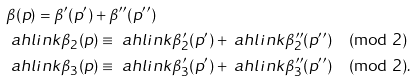<formula> <loc_0><loc_0><loc_500><loc_500>& \beta ( p ) = \beta ^ { \prime } ( p ^ { \prime } ) + \beta ^ { \prime \prime } ( p ^ { \prime \prime } ) \\ & \ a h l i n k \beta _ { 2 } ( p ) \equiv \ a h l i n k \beta ^ { \prime } _ { 2 } ( p ^ { \prime } ) + \ a h l i n k \beta ^ { \prime \prime } _ { 2 } ( p ^ { \prime \prime } ) \pmod { 2 } \\ & \ a h l i n k \beta _ { 3 } ( p ) \equiv \ a h l i n k \beta ^ { \prime } _ { 3 } ( p ^ { \prime } ) + \ a h l i n k \beta ^ { \prime \prime } _ { 3 } ( p ^ { \prime \prime } ) \pmod { 2 } .</formula> 